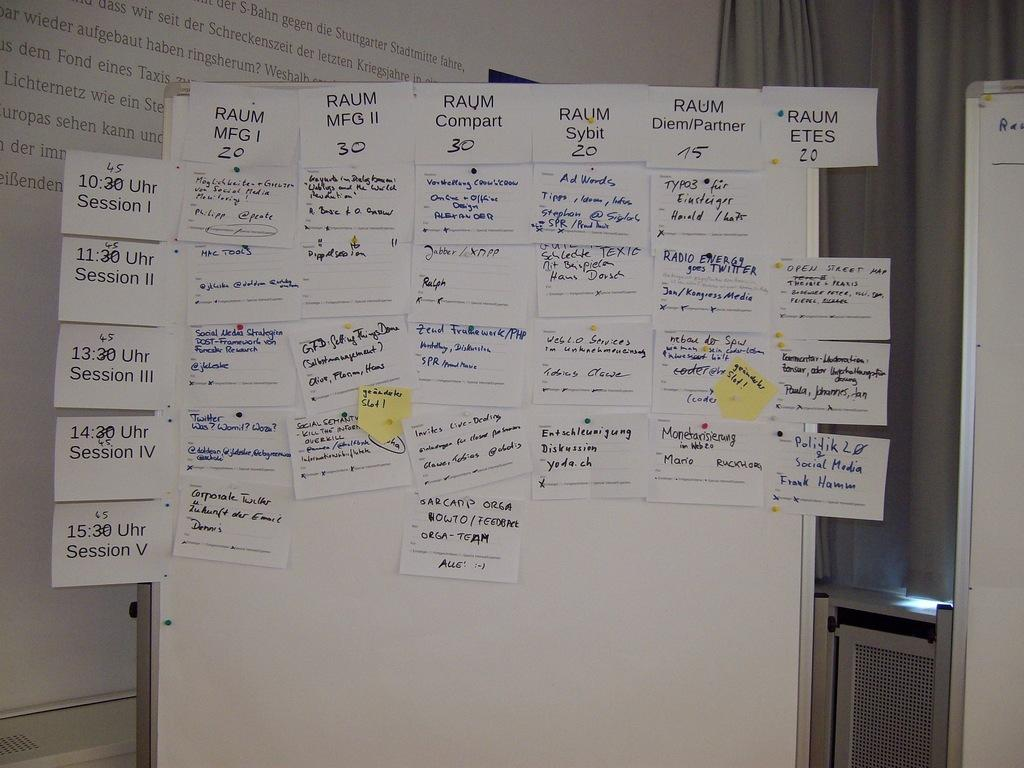Provide a one-sentence caption for the provided image. Session one of the event is at 10:45. 